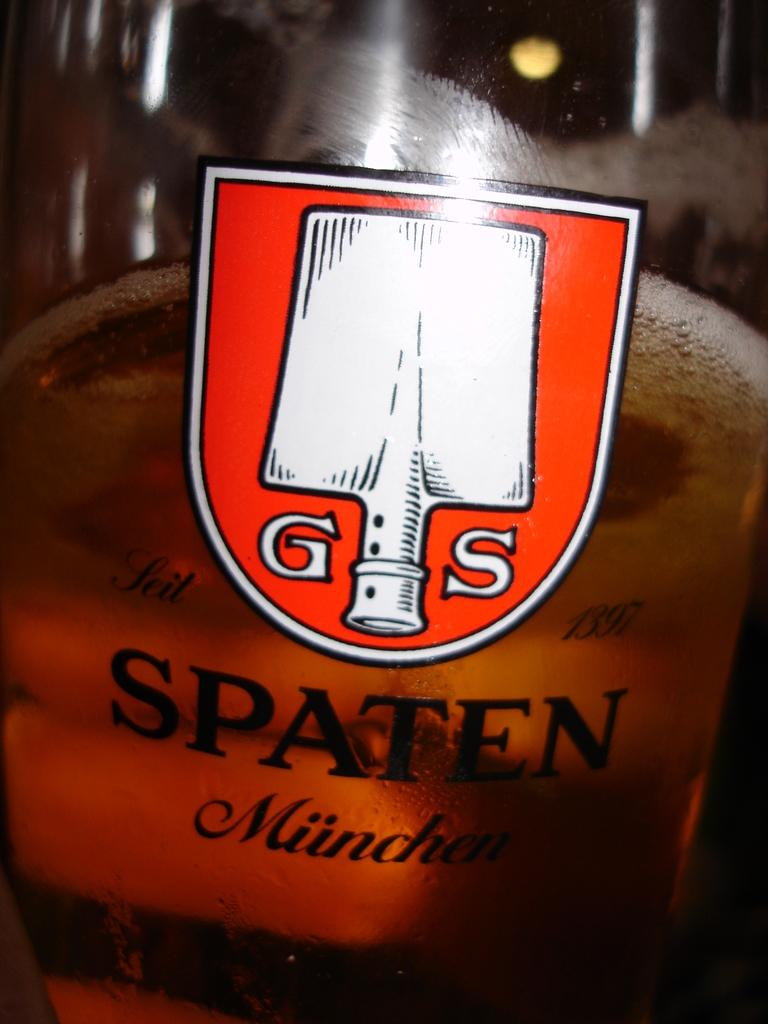<image>
Create a compact narrative representing the image presented. A glass of beer that has the label Spaten. 